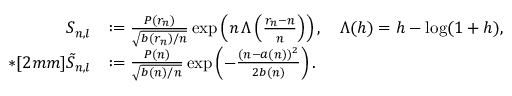<formula> <loc_0><loc_0><loc_500><loc_500>\begin{array} { r l } { S _ { n , l } } & { \colon = \frac { P ( r _ { n } ) } { \sqrt { b ( r _ { n } ) / n } } \exp \left ( n \, \Lambda \left ( \frac { r _ { n } - n } n \right ) \right ) , \quad \Lambda ( h ) = h - \log ( 1 + h ) , } \\ { * [ 2 m m ] \tilde { S } _ { n , l } } & { \colon = \frac { P ( n ) } { \sqrt { b ( n ) / n } } \exp \left ( - \frac { ( n - a ( n ) ) ^ { 2 } } { 2 b ( n ) } \right ) . } \end{array}</formula> 